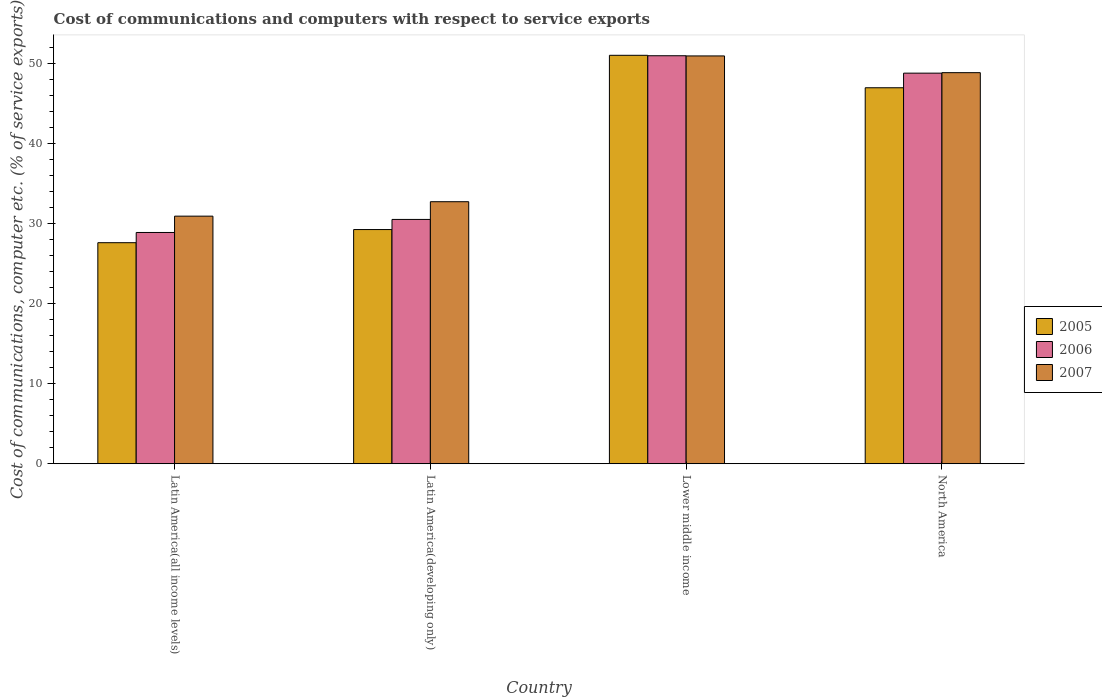How many different coloured bars are there?
Ensure brevity in your answer.  3. How many groups of bars are there?
Your response must be concise. 4. How many bars are there on the 3rd tick from the left?
Make the answer very short. 3. How many bars are there on the 3rd tick from the right?
Your answer should be compact. 3. What is the label of the 3rd group of bars from the left?
Your answer should be compact. Lower middle income. What is the cost of communications and computers in 2006 in Latin America(developing only)?
Provide a short and direct response. 30.5. Across all countries, what is the maximum cost of communications and computers in 2006?
Give a very brief answer. 50.93. Across all countries, what is the minimum cost of communications and computers in 2006?
Ensure brevity in your answer.  28.87. In which country was the cost of communications and computers in 2005 maximum?
Give a very brief answer. Lower middle income. In which country was the cost of communications and computers in 2007 minimum?
Provide a succinct answer. Latin America(all income levels). What is the total cost of communications and computers in 2006 in the graph?
Ensure brevity in your answer.  159.05. What is the difference between the cost of communications and computers in 2006 in Latin America(all income levels) and that in North America?
Ensure brevity in your answer.  -19.89. What is the difference between the cost of communications and computers in 2005 in North America and the cost of communications and computers in 2007 in Latin America(developing only)?
Keep it short and to the point. 14.23. What is the average cost of communications and computers in 2007 per country?
Provide a succinct answer. 40.83. What is the difference between the cost of communications and computers of/in 2005 and cost of communications and computers of/in 2007 in Lower middle income?
Your answer should be compact. 0.08. In how many countries, is the cost of communications and computers in 2007 greater than 10 %?
Keep it short and to the point. 4. What is the ratio of the cost of communications and computers in 2007 in Lower middle income to that in North America?
Make the answer very short. 1.04. What is the difference between the highest and the second highest cost of communications and computers in 2006?
Offer a terse response. -2.17. What is the difference between the highest and the lowest cost of communications and computers in 2006?
Give a very brief answer. 22.06. What does the 1st bar from the left in Latin America(all income levels) represents?
Provide a short and direct response. 2005. What does the 1st bar from the right in Latin America(developing only) represents?
Offer a terse response. 2007. What is the difference between two consecutive major ticks on the Y-axis?
Provide a succinct answer. 10. Does the graph contain any zero values?
Provide a short and direct response. No. How are the legend labels stacked?
Give a very brief answer. Vertical. What is the title of the graph?
Your answer should be very brief. Cost of communications and computers with respect to service exports. What is the label or title of the Y-axis?
Provide a short and direct response. Cost of communications, computer etc. (% of service exports). What is the Cost of communications, computer etc. (% of service exports) in 2005 in Latin America(all income levels)?
Your answer should be compact. 27.59. What is the Cost of communications, computer etc. (% of service exports) in 2006 in Latin America(all income levels)?
Your response must be concise. 28.87. What is the Cost of communications, computer etc. (% of service exports) in 2007 in Latin America(all income levels)?
Provide a succinct answer. 30.91. What is the Cost of communications, computer etc. (% of service exports) in 2005 in Latin America(developing only)?
Ensure brevity in your answer.  29.23. What is the Cost of communications, computer etc. (% of service exports) in 2006 in Latin America(developing only)?
Your answer should be compact. 30.5. What is the Cost of communications, computer etc. (% of service exports) of 2007 in Latin America(developing only)?
Your answer should be very brief. 32.71. What is the Cost of communications, computer etc. (% of service exports) in 2005 in Lower middle income?
Give a very brief answer. 50.99. What is the Cost of communications, computer etc. (% of service exports) in 2006 in Lower middle income?
Offer a terse response. 50.93. What is the Cost of communications, computer etc. (% of service exports) of 2007 in Lower middle income?
Make the answer very short. 50.91. What is the Cost of communications, computer etc. (% of service exports) of 2005 in North America?
Your answer should be very brief. 46.93. What is the Cost of communications, computer etc. (% of service exports) of 2006 in North America?
Keep it short and to the point. 48.76. What is the Cost of communications, computer etc. (% of service exports) of 2007 in North America?
Give a very brief answer. 48.82. Across all countries, what is the maximum Cost of communications, computer etc. (% of service exports) of 2005?
Your answer should be very brief. 50.99. Across all countries, what is the maximum Cost of communications, computer etc. (% of service exports) of 2006?
Ensure brevity in your answer.  50.93. Across all countries, what is the maximum Cost of communications, computer etc. (% of service exports) in 2007?
Ensure brevity in your answer.  50.91. Across all countries, what is the minimum Cost of communications, computer etc. (% of service exports) of 2005?
Offer a very short reply. 27.59. Across all countries, what is the minimum Cost of communications, computer etc. (% of service exports) of 2006?
Offer a very short reply. 28.87. Across all countries, what is the minimum Cost of communications, computer etc. (% of service exports) in 2007?
Keep it short and to the point. 30.91. What is the total Cost of communications, computer etc. (% of service exports) of 2005 in the graph?
Offer a very short reply. 154.75. What is the total Cost of communications, computer etc. (% of service exports) in 2006 in the graph?
Your answer should be compact. 159.05. What is the total Cost of communications, computer etc. (% of service exports) in 2007 in the graph?
Make the answer very short. 163.34. What is the difference between the Cost of communications, computer etc. (% of service exports) of 2005 in Latin America(all income levels) and that in Latin America(developing only)?
Make the answer very short. -1.64. What is the difference between the Cost of communications, computer etc. (% of service exports) in 2006 in Latin America(all income levels) and that in Latin America(developing only)?
Keep it short and to the point. -1.63. What is the difference between the Cost of communications, computer etc. (% of service exports) of 2007 in Latin America(all income levels) and that in Latin America(developing only)?
Offer a very short reply. -1.8. What is the difference between the Cost of communications, computer etc. (% of service exports) in 2005 in Latin America(all income levels) and that in Lower middle income?
Your answer should be very brief. -23.39. What is the difference between the Cost of communications, computer etc. (% of service exports) in 2006 in Latin America(all income levels) and that in Lower middle income?
Offer a very short reply. -22.06. What is the difference between the Cost of communications, computer etc. (% of service exports) in 2007 in Latin America(all income levels) and that in Lower middle income?
Your response must be concise. -20. What is the difference between the Cost of communications, computer etc. (% of service exports) of 2005 in Latin America(all income levels) and that in North America?
Offer a very short reply. -19.34. What is the difference between the Cost of communications, computer etc. (% of service exports) in 2006 in Latin America(all income levels) and that in North America?
Offer a very short reply. -19.89. What is the difference between the Cost of communications, computer etc. (% of service exports) of 2007 in Latin America(all income levels) and that in North America?
Give a very brief answer. -17.91. What is the difference between the Cost of communications, computer etc. (% of service exports) of 2005 in Latin America(developing only) and that in Lower middle income?
Your answer should be compact. -21.75. What is the difference between the Cost of communications, computer etc. (% of service exports) in 2006 in Latin America(developing only) and that in Lower middle income?
Your answer should be compact. -20.43. What is the difference between the Cost of communications, computer etc. (% of service exports) of 2007 in Latin America(developing only) and that in Lower middle income?
Your answer should be compact. -18.2. What is the difference between the Cost of communications, computer etc. (% of service exports) of 2005 in Latin America(developing only) and that in North America?
Your answer should be very brief. -17.7. What is the difference between the Cost of communications, computer etc. (% of service exports) of 2006 in Latin America(developing only) and that in North America?
Offer a terse response. -18.26. What is the difference between the Cost of communications, computer etc. (% of service exports) of 2007 in Latin America(developing only) and that in North America?
Offer a very short reply. -16.11. What is the difference between the Cost of communications, computer etc. (% of service exports) of 2005 in Lower middle income and that in North America?
Keep it short and to the point. 4.05. What is the difference between the Cost of communications, computer etc. (% of service exports) of 2006 in Lower middle income and that in North America?
Offer a very short reply. 2.17. What is the difference between the Cost of communications, computer etc. (% of service exports) in 2007 in Lower middle income and that in North America?
Your answer should be very brief. 2.09. What is the difference between the Cost of communications, computer etc. (% of service exports) of 2005 in Latin America(all income levels) and the Cost of communications, computer etc. (% of service exports) of 2006 in Latin America(developing only)?
Give a very brief answer. -2.9. What is the difference between the Cost of communications, computer etc. (% of service exports) of 2005 in Latin America(all income levels) and the Cost of communications, computer etc. (% of service exports) of 2007 in Latin America(developing only)?
Offer a terse response. -5.11. What is the difference between the Cost of communications, computer etc. (% of service exports) of 2006 in Latin America(all income levels) and the Cost of communications, computer etc. (% of service exports) of 2007 in Latin America(developing only)?
Your response must be concise. -3.84. What is the difference between the Cost of communications, computer etc. (% of service exports) in 2005 in Latin America(all income levels) and the Cost of communications, computer etc. (% of service exports) in 2006 in Lower middle income?
Ensure brevity in your answer.  -23.34. What is the difference between the Cost of communications, computer etc. (% of service exports) of 2005 in Latin America(all income levels) and the Cost of communications, computer etc. (% of service exports) of 2007 in Lower middle income?
Make the answer very short. -23.31. What is the difference between the Cost of communications, computer etc. (% of service exports) in 2006 in Latin America(all income levels) and the Cost of communications, computer etc. (% of service exports) in 2007 in Lower middle income?
Offer a terse response. -22.04. What is the difference between the Cost of communications, computer etc. (% of service exports) in 2005 in Latin America(all income levels) and the Cost of communications, computer etc. (% of service exports) in 2006 in North America?
Make the answer very short. -21.16. What is the difference between the Cost of communications, computer etc. (% of service exports) in 2005 in Latin America(all income levels) and the Cost of communications, computer etc. (% of service exports) in 2007 in North America?
Provide a succinct answer. -21.22. What is the difference between the Cost of communications, computer etc. (% of service exports) in 2006 in Latin America(all income levels) and the Cost of communications, computer etc. (% of service exports) in 2007 in North America?
Offer a terse response. -19.95. What is the difference between the Cost of communications, computer etc. (% of service exports) of 2005 in Latin America(developing only) and the Cost of communications, computer etc. (% of service exports) of 2006 in Lower middle income?
Your answer should be very brief. -21.7. What is the difference between the Cost of communications, computer etc. (% of service exports) in 2005 in Latin America(developing only) and the Cost of communications, computer etc. (% of service exports) in 2007 in Lower middle income?
Provide a succinct answer. -21.67. What is the difference between the Cost of communications, computer etc. (% of service exports) in 2006 in Latin America(developing only) and the Cost of communications, computer etc. (% of service exports) in 2007 in Lower middle income?
Ensure brevity in your answer.  -20.41. What is the difference between the Cost of communications, computer etc. (% of service exports) of 2005 in Latin America(developing only) and the Cost of communications, computer etc. (% of service exports) of 2006 in North America?
Provide a succinct answer. -19.53. What is the difference between the Cost of communications, computer etc. (% of service exports) in 2005 in Latin America(developing only) and the Cost of communications, computer etc. (% of service exports) in 2007 in North America?
Provide a short and direct response. -19.59. What is the difference between the Cost of communications, computer etc. (% of service exports) of 2006 in Latin America(developing only) and the Cost of communications, computer etc. (% of service exports) of 2007 in North America?
Provide a short and direct response. -18.32. What is the difference between the Cost of communications, computer etc. (% of service exports) of 2005 in Lower middle income and the Cost of communications, computer etc. (% of service exports) of 2006 in North America?
Your answer should be compact. 2.23. What is the difference between the Cost of communications, computer etc. (% of service exports) of 2005 in Lower middle income and the Cost of communications, computer etc. (% of service exports) of 2007 in North America?
Offer a very short reply. 2.17. What is the difference between the Cost of communications, computer etc. (% of service exports) of 2006 in Lower middle income and the Cost of communications, computer etc. (% of service exports) of 2007 in North America?
Your answer should be very brief. 2.11. What is the average Cost of communications, computer etc. (% of service exports) of 2005 per country?
Your answer should be compact. 38.69. What is the average Cost of communications, computer etc. (% of service exports) in 2006 per country?
Your answer should be very brief. 39.76. What is the average Cost of communications, computer etc. (% of service exports) of 2007 per country?
Your answer should be compact. 40.83. What is the difference between the Cost of communications, computer etc. (% of service exports) in 2005 and Cost of communications, computer etc. (% of service exports) in 2006 in Latin America(all income levels)?
Keep it short and to the point. -1.27. What is the difference between the Cost of communications, computer etc. (% of service exports) in 2005 and Cost of communications, computer etc. (% of service exports) in 2007 in Latin America(all income levels)?
Offer a very short reply. -3.31. What is the difference between the Cost of communications, computer etc. (% of service exports) of 2006 and Cost of communications, computer etc. (% of service exports) of 2007 in Latin America(all income levels)?
Your answer should be very brief. -2.04. What is the difference between the Cost of communications, computer etc. (% of service exports) of 2005 and Cost of communications, computer etc. (% of service exports) of 2006 in Latin America(developing only)?
Keep it short and to the point. -1.26. What is the difference between the Cost of communications, computer etc. (% of service exports) of 2005 and Cost of communications, computer etc. (% of service exports) of 2007 in Latin America(developing only)?
Provide a succinct answer. -3.48. What is the difference between the Cost of communications, computer etc. (% of service exports) in 2006 and Cost of communications, computer etc. (% of service exports) in 2007 in Latin America(developing only)?
Provide a succinct answer. -2.21. What is the difference between the Cost of communications, computer etc. (% of service exports) of 2005 and Cost of communications, computer etc. (% of service exports) of 2006 in Lower middle income?
Make the answer very short. 0.06. What is the difference between the Cost of communications, computer etc. (% of service exports) of 2005 and Cost of communications, computer etc. (% of service exports) of 2007 in Lower middle income?
Your response must be concise. 0.08. What is the difference between the Cost of communications, computer etc. (% of service exports) in 2006 and Cost of communications, computer etc. (% of service exports) in 2007 in Lower middle income?
Make the answer very short. 0.02. What is the difference between the Cost of communications, computer etc. (% of service exports) of 2005 and Cost of communications, computer etc. (% of service exports) of 2006 in North America?
Provide a succinct answer. -1.82. What is the difference between the Cost of communications, computer etc. (% of service exports) in 2005 and Cost of communications, computer etc. (% of service exports) in 2007 in North America?
Offer a terse response. -1.88. What is the difference between the Cost of communications, computer etc. (% of service exports) of 2006 and Cost of communications, computer etc. (% of service exports) of 2007 in North America?
Provide a short and direct response. -0.06. What is the ratio of the Cost of communications, computer etc. (% of service exports) in 2005 in Latin America(all income levels) to that in Latin America(developing only)?
Offer a very short reply. 0.94. What is the ratio of the Cost of communications, computer etc. (% of service exports) in 2006 in Latin America(all income levels) to that in Latin America(developing only)?
Provide a succinct answer. 0.95. What is the ratio of the Cost of communications, computer etc. (% of service exports) of 2007 in Latin America(all income levels) to that in Latin America(developing only)?
Your answer should be compact. 0.94. What is the ratio of the Cost of communications, computer etc. (% of service exports) in 2005 in Latin America(all income levels) to that in Lower middle income?
Ensure brevity in your answer.  0.54. What is the ratio of the Cost of communications, computer etc. (% of service exports) of 2006 in Latin America(all income levels) to that in Lower middle income?
Keep it short and to the point. 0.57. What is the ratio of the Cost of communications, computer etc. (% of service exports) in 2007 in Latin America(all income levels) to that in Lower middle income?
Give a very brief answer. 0.61. What is the ratio of the Cost of communications, computer etc. (% of service exports) in 2005 in Latin America(all income levels) to that in North America?
Your answer should be very brief. 0.59. What is the ratio of the Cost of communications, computer etc. (% of service exports) in 2006 in Latin America(all income levels) to that in North America?
Your answer should be compact. 0.59. What is the ratio of the Cost of communications, computer etc. (% of service exports) in 2007 in Latin America(all income levels) to that in North America?
Make the answer very short. 0.63. What is the ratio of the Cost of communications, computer etc. (% of service exports) in 2005 in Latin America(developing only) to that in Lower middle income?
Offer a terse response. 0.57. What is the ratio of the Cost of communications, computer etc. (% of service exports) in 2006 in Latin America(developing only) to that in Lower middle income?
Provide a short and direct response. 0.6. What is the ratio of the Cost of communications, computer etc. (% of service exports) of 2007 in Latin America(developing only) to that in Lower middle income?
Your answer should be very brief. 0.64. What is the ratio of the Cost of communications, computer etc. (% of service exports) of 2005 in Latin America(developing only) to that in North America?
Ensure brevity in your answer.  0.62. What is the ratio of the Cost of communications, computer etc. (% of service exports) in 2006 in Latin America(developing only) to that in North America?
Offer a very short reply. 0.63. What is the ratio of the Cost of communications, computer etc. (% of service exports) in 2007 in Latin America(developing only) to that in North America?
Give a very brief answer. 0.67. What is the ratio of the Cost of communications, computer etc. (% of service exports) of 2005 in Lower middle income to that in North America?
Keep it short and to the point. 1.09. What is the ratio of the Cost of communications, computer etc. (% of service exports) in 2006 in Lower middle income to that in North America?
Ensure brevity in your answer.  1.04. What is the ratio of the Cost of communications, computer etc. (% of service exports) of 2007 in Lower middle income to that in North America?
Your answer should be very brief. 1.04. What is the difference between the highest and the second highest Cost of communications, computer etc. (% of service exports) of 2005?
Provide a short and direct response. 4.05. What is the difference between the highest and the second highest Cost of communications, computer etc. (% of service exports) in 2006?
Provide a succinct answer. 2.17. What is the difference between the highest and the second highest Cost of communications, computer etc. (% of service exports) in 2007?
Give a very brief answer. 2.09. What is the difference between the highest and the lowest Cost of communications, computer etc. (% of service exports) in 2005?
Make the answer very short. 23.39. What is the difference between the highest and the lowest Cost of communications, computer etc. (% of service exports) of 2006?
Provide a succinct answer. 22.06. What is the difference between the highest and the lowest Cost of communications, computer etc. (% of service exports) of 2007?
Offer a very short reply. 20. 